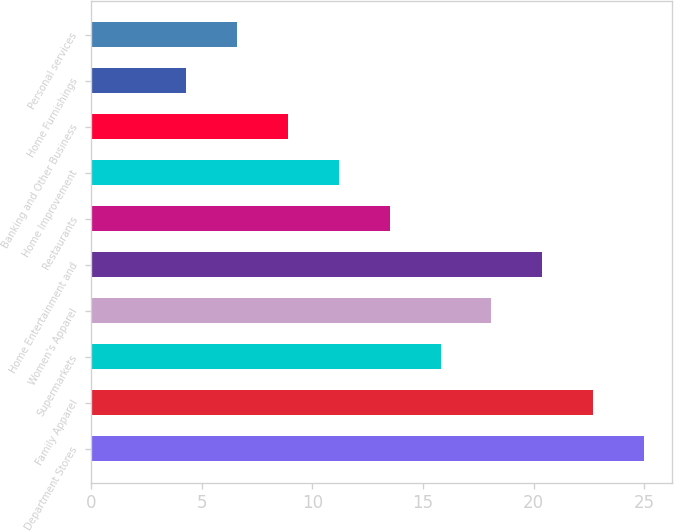<chart> <loc_0><loc_0><loc_500><loc_500><bar_chart><fcel>Department Stores<fcel>Family Apparel<fcel>Supermarkets<fcel>Women's Apparel<fcel>Home Entertainment and<fcel>Restaurants<fcel>Home Improvement<fcel>Banking and Other Business<fcel>Home Furnishings<fcel>Personal services<nl><fcel>25<fcel>22.7<fcel>15.8<fcel>18.1<fcel>20.4<fcel>13.5<fcel>11.2<fcel>8.9<fcel>4.3<fcel>6.6<nl></chart> 